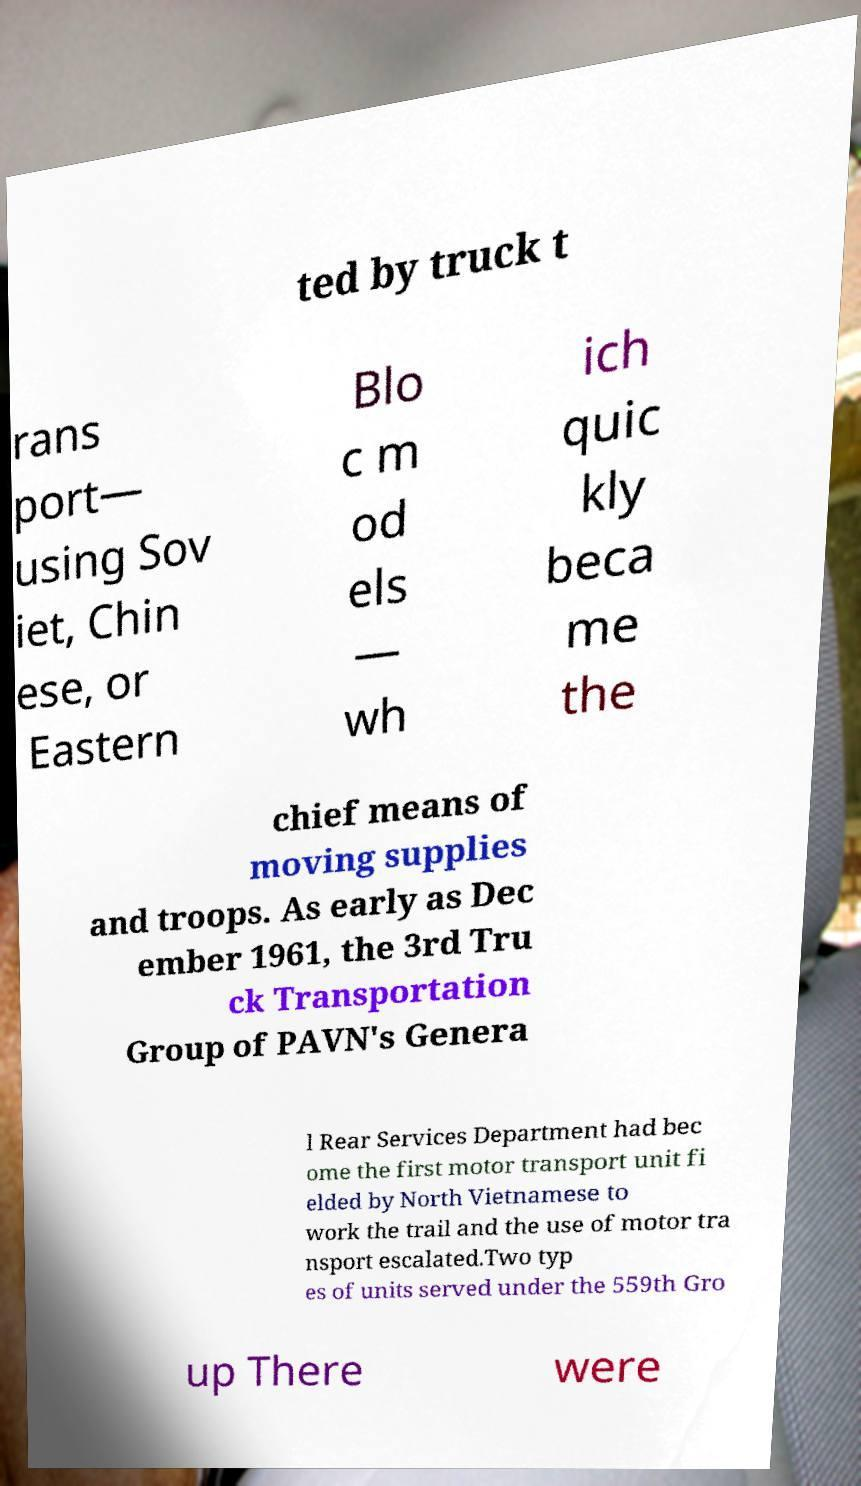Could you extract and type out the text from this image? ted by truck t rans port— using Sov iet, Chin ese, or Eastern Blo c m od els — wh ich quic kly beca me the chief means of moving supplies and troops. As early as Dec ember 1961, the 3rd Tru ck Transportation Group of PAVN's Genera l Rear Services Department had bec ome the first motor transport unit fi elded by North Vietnamese to work the trail and the use of motor tra nsport escalated.Two typ es of units served under the 559th Gro up There were 